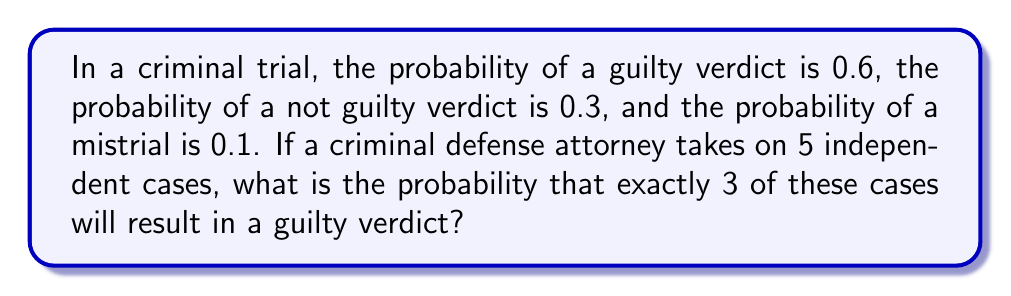Provide a solution to this math problem. To solve this problem, we'll use the binomial probability formula:

$$P(X = k) = \binom{n}{k} p^k (1-p)^{n-k}$$

Where:
$n$ = number of trials (cases) = 5
$k$ = number of successes (guilty verdicts) = 3
$p$ = probability of success (guilty verdict) = 0.6

Step 1: Calculate the binomial coefficient
$$\binom{5}{3} = \frac{5!}{3!(5-3)!} = \frac{5 \cdot 4}{2 \cdot 1} = 10$$

Step 2: Apply the binomial probability formula
$$P(X = 3) = 10 \cdot (0.6)^3 \cdot (1-0.6)^{5-3}$$
$$= 10 \cdot (0.6)^3 \cdot (0.4)^2$$

Step 3: Calculate the final probability
$$= 10 \cdot 0.216 \cdot 0.16$$
$$= 0.3456$$

Therefore, the probability of exactly 3 guilty verdicts out of 5 cases is 0.3456 or 34.56%.
Answer: 0.3456 